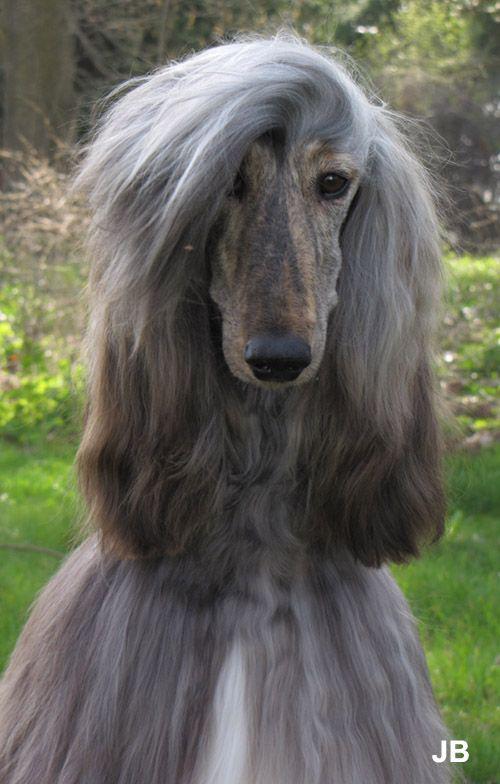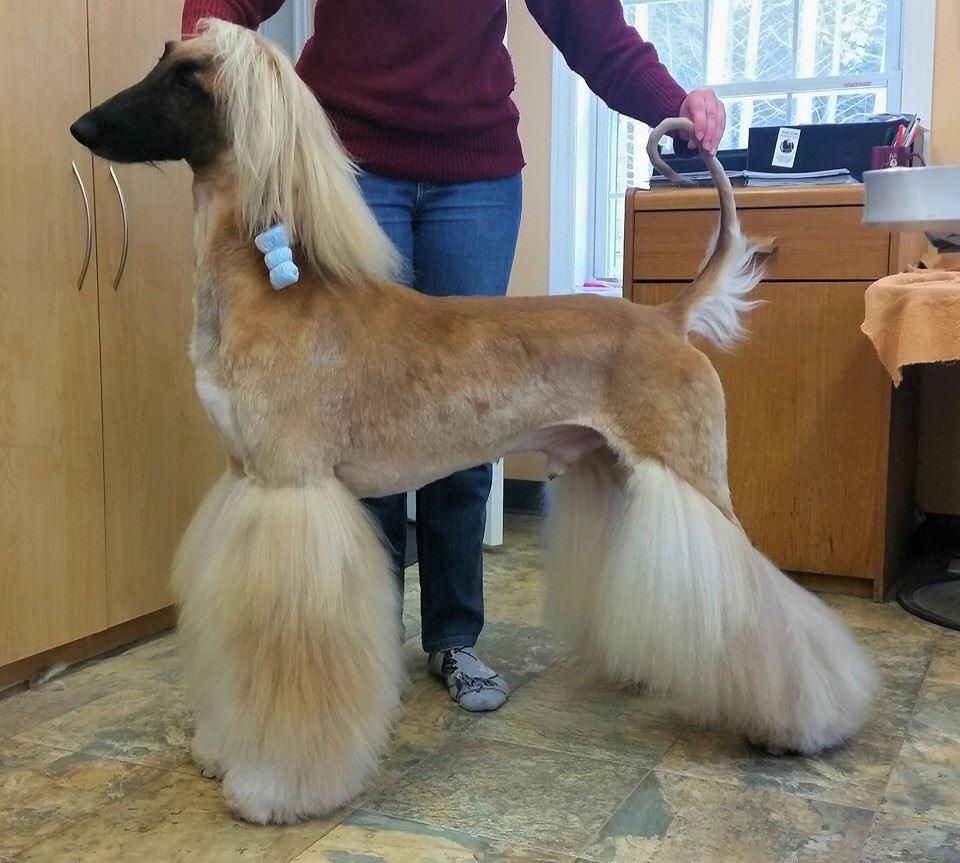The first image is the image on the left, the second image is the image on the right. For the images displayed, is the sentence "In at least one image there is a single dog with bangs the cover part of one eye." factually correct? Answer yes or no. Yes. 